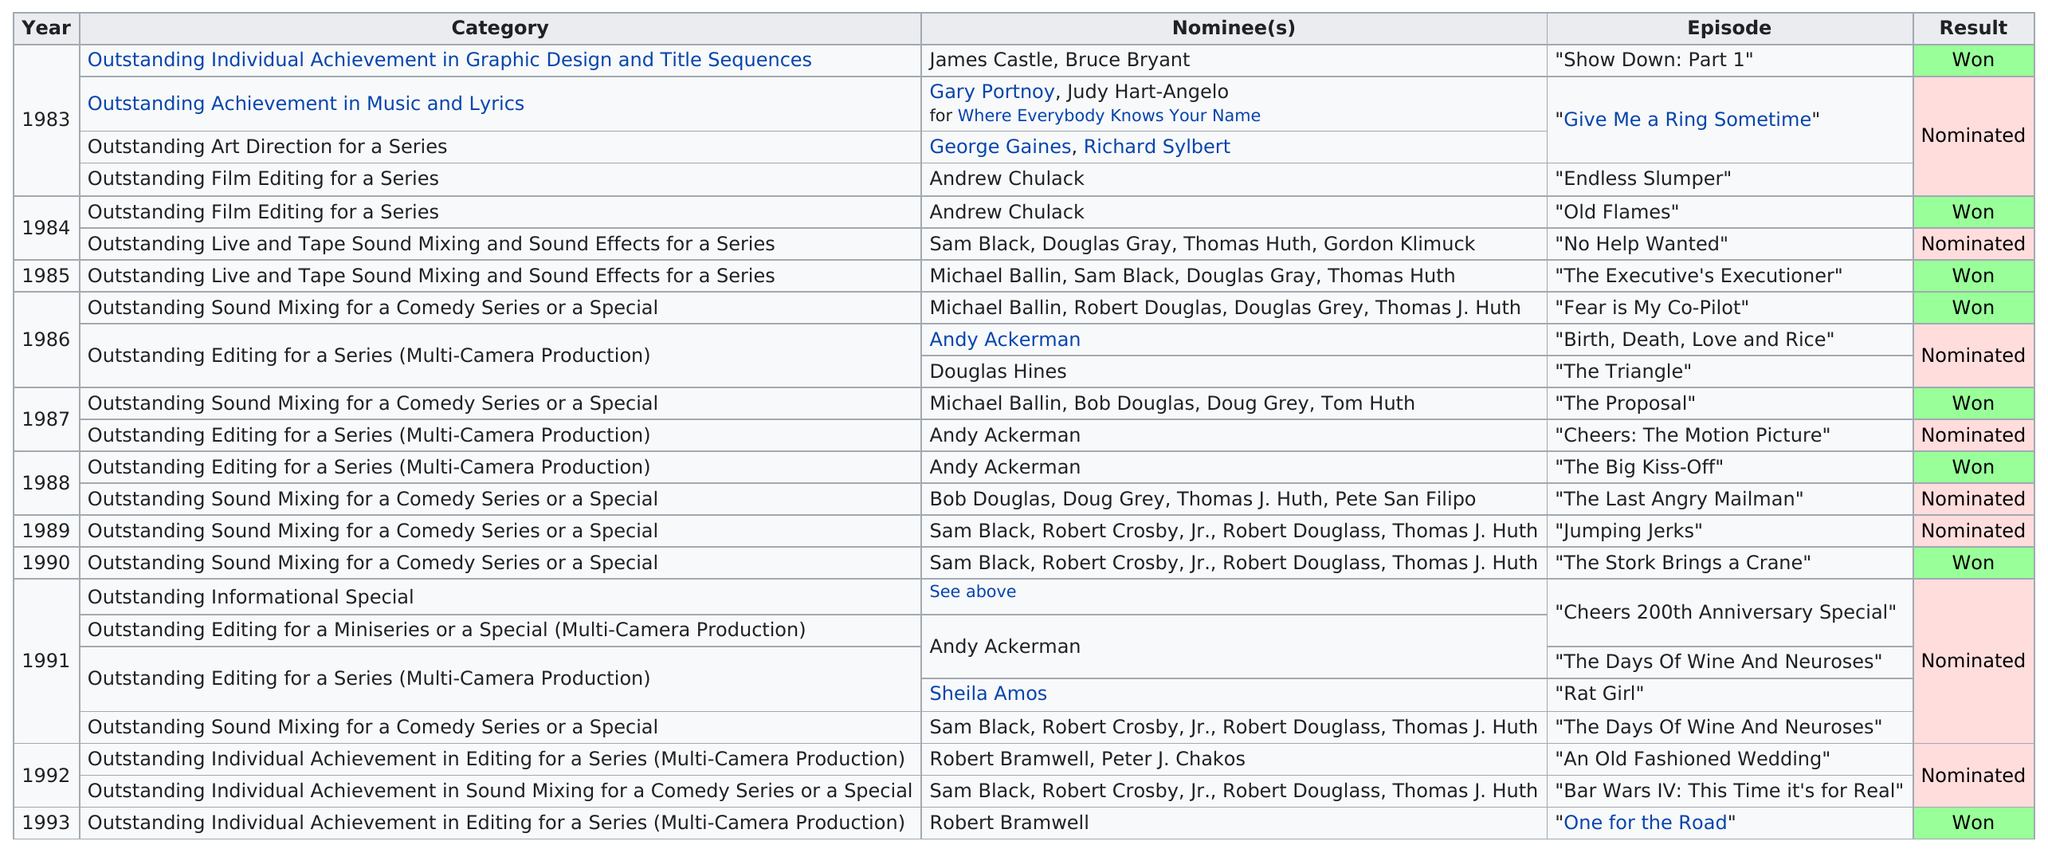List a handful of essential elements in this visual. Outstanding film editing for a series was won by [a specific number] episodes. In 1984, Sam Black was nominated for the first time. Fear is My Co-Pilot" was preceded by "Birth, Death, Love and Rice" as the next episode nominated for an Emmy Award. In the year that he was nominated for "Cheers: The Motion Picture," it was 1987. Thirty-three wins were recorded after 1987. 